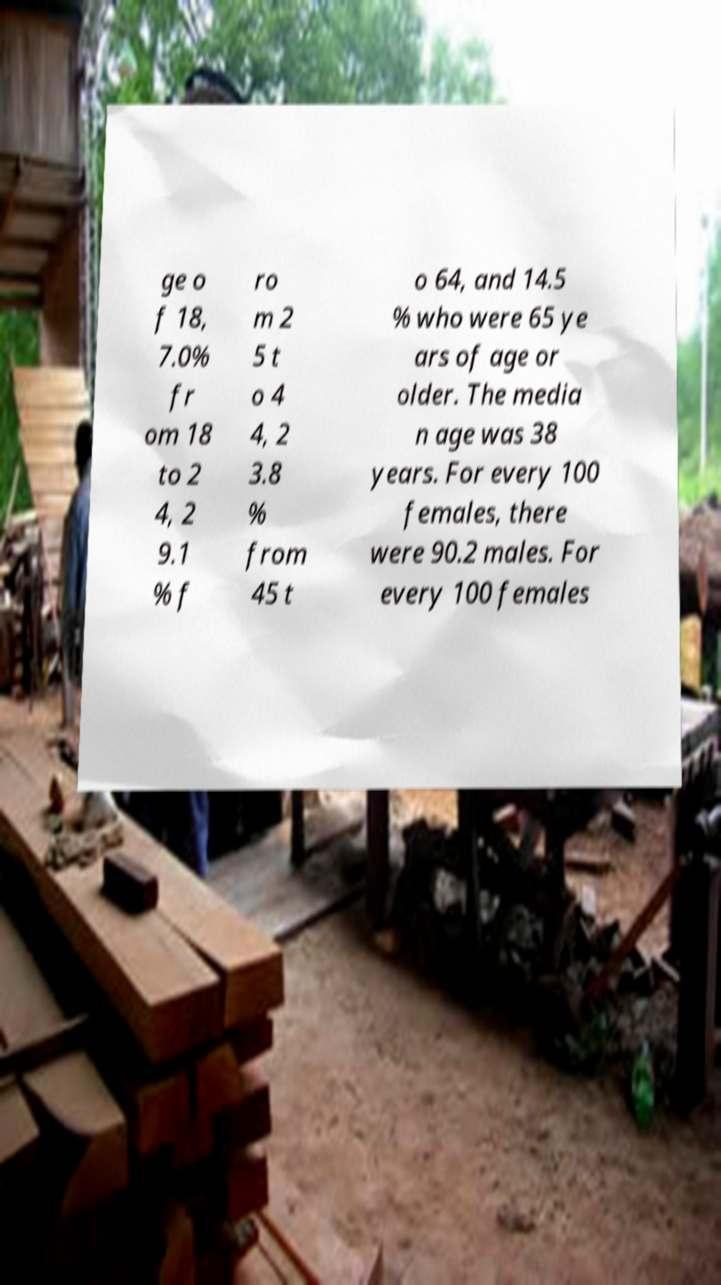Could you extract and type out the text from this image? ge o f 18, 7.0% fr om 18 to 2 4, 2 9.1 % f ro m 2 5 t o 4 4, 2 3.8 % from 45 t o 64, and 14.5 % who were 65 ye ars of age or older. The media n age was 38 years. For every 100 females, there were 90.2 males. For every 100 females 